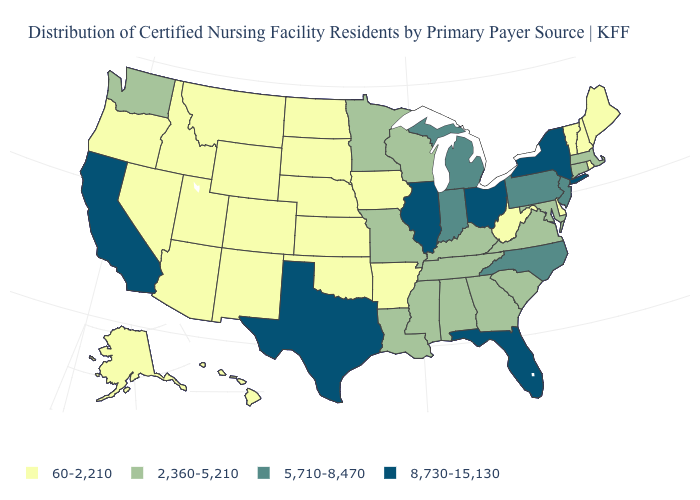What is the lowest value in the USA?
Keep it brief. 60-2,210. Which states have the lowest value in the MidWest?
Be succinct. Iowa, Kansas, Nebraska, North Dakota, South Dakota. What is the highest value in the USA?
Give a very brief answer. 8,730-15,130. Name the states that have a value in the range 60-2,210?
Give a very brief answer. Alaska, Arizona, Arkansas, Colorado, Delaware, Hawaii, Idaho, Iowa, Kansas, Maine, Montana, Nebraska, Nevada, New Hampshire, New Mexico, North Dakota, Oklahoma, Oregon, Rhode Island, South Dakota, Utah, Vermont, West Virginia, Wyoming. What is the value of Washington?
Quick response, please. 2,360-5,210. Among the states that border Wyoming , which have the highest value?
Be succinct. Colorado, Idaho, Montana, Nebraska, South Dakota, Utah. Does Michigan have the lowest value in the USA?
Write a very short answer. No. Which states have the highest value in the USA?
Write a very short answer. California, Florida, Illinois, New York, Ohio, Texas. Which states hav the highest value in the West?
Short answer required. California. Among the states that border Arizona , does Colorado have the lowest value?
Be succinct. Yes. What is the lowest value in the MidWest?
Short answer required. 60-2,210. What is the value of North Carolina?
Concise answer only. 5,710-8,470. What is the value of South Carolina?
Be succinct. 2,360-5,210. Which states have the lowest value in the USA?
Short answer required. Alaska, Arizona, Arkansas, Colorado, Delaware, Hawaii, Idaho, Iowa, Kansas, Maine, Montana, Nebraska, Nevada, New Hampshire, New Mexico, North Dakota, Oklahoma, Oregon, Rhode Island, South Dakota, Utah, Vermont, West Virginia, Wyoming. What is the highest value in the West ?
Concise answer only. 8,730-15,130. 